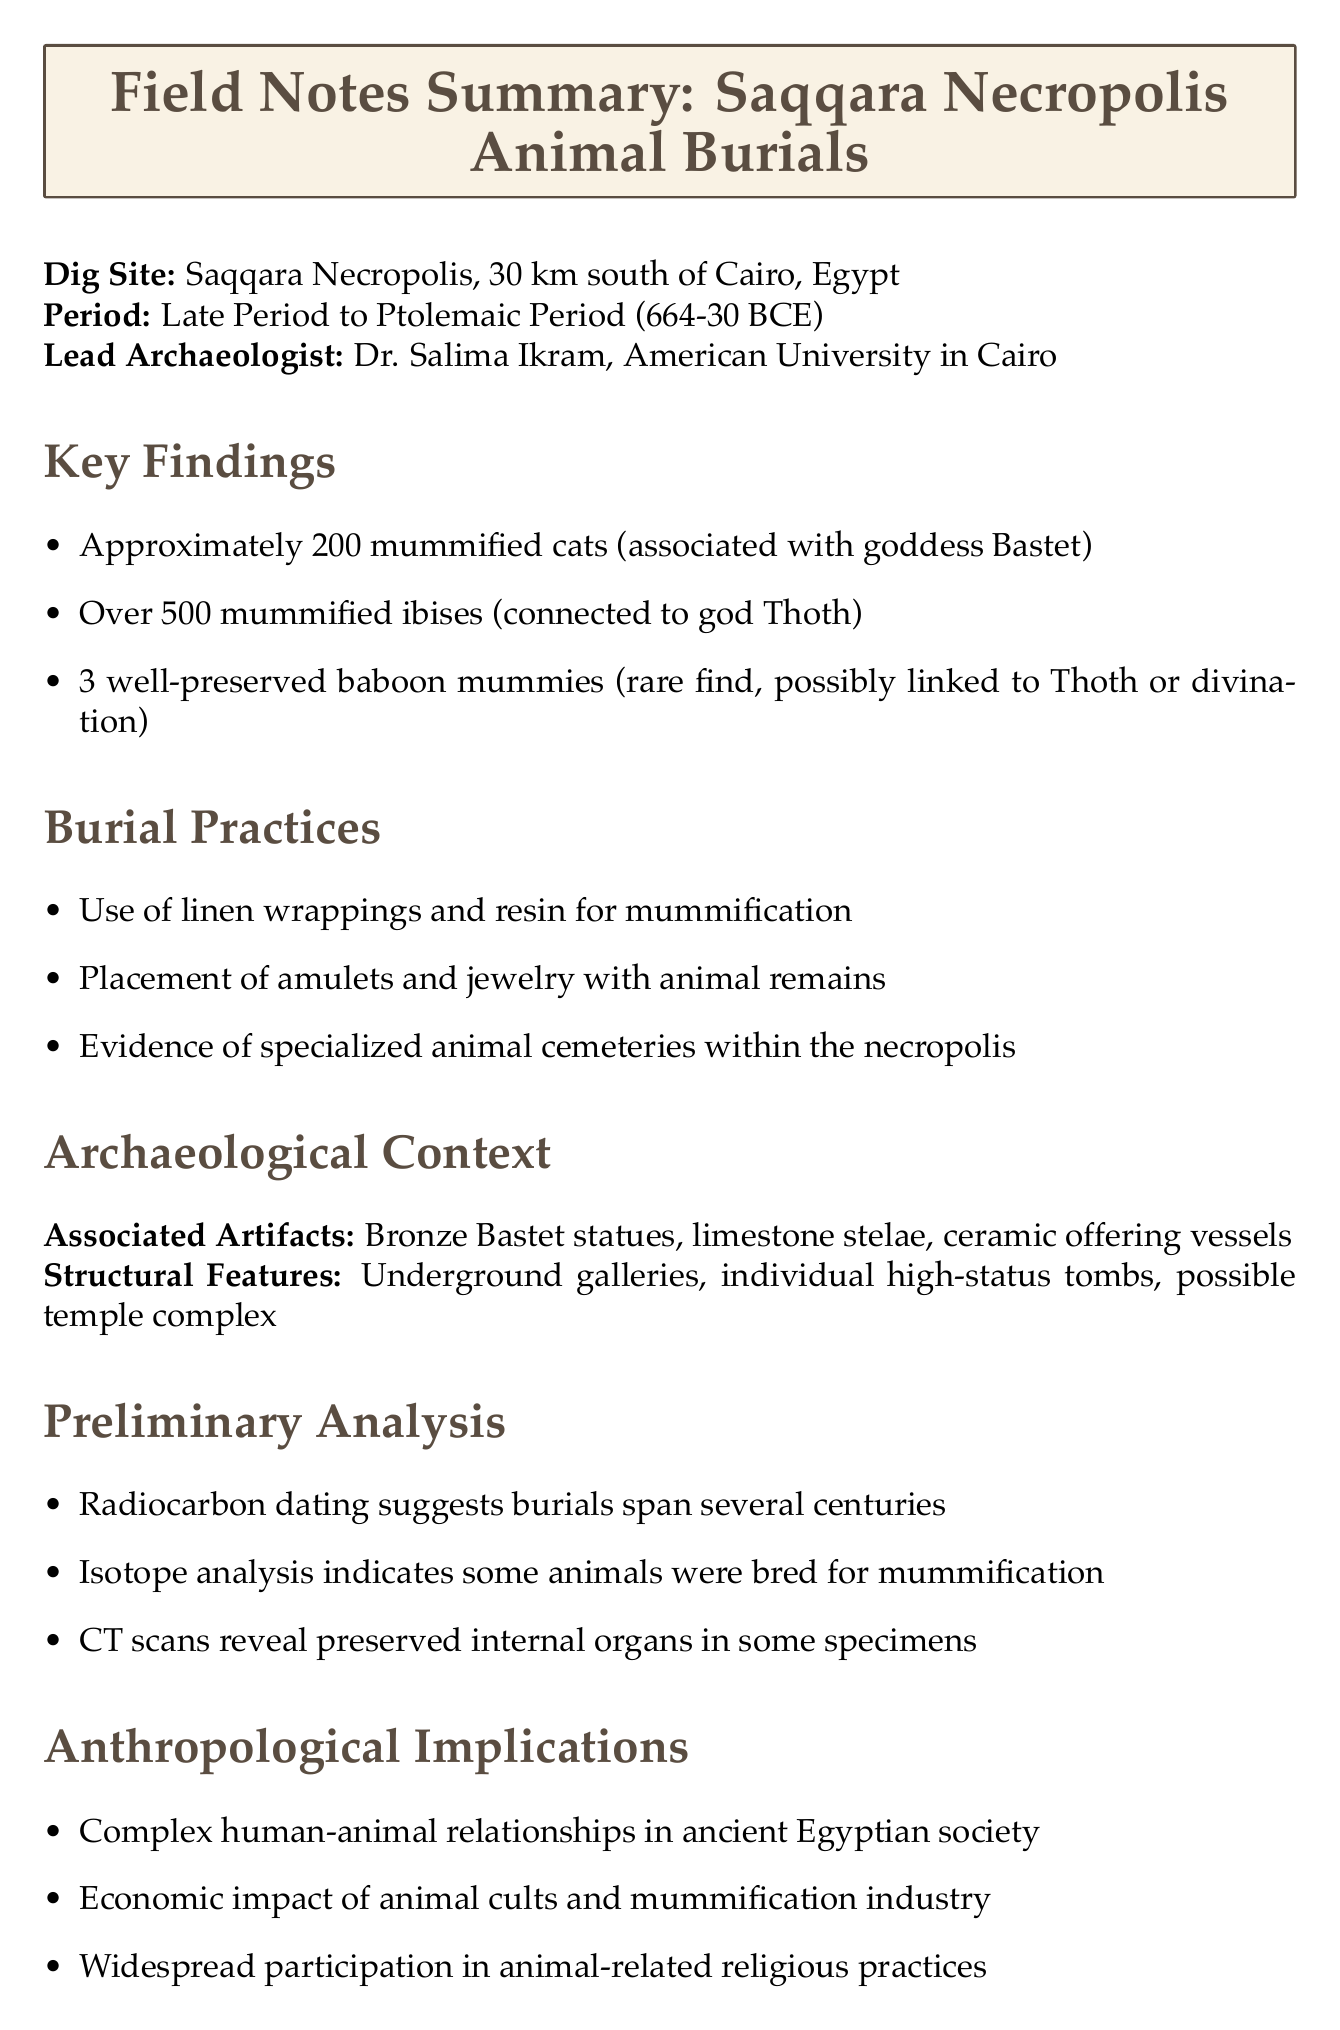What is the location of the dig site? The location of the dig site is specified in the document as 30 km south of Cairo, Egypt.
Answer: 30 km south of Cairo, Egypt Who is the lead archaeologist? The document provides the name and affiliation of the lead archaeologist involved in the dig.
Answer: Dr. Salima Ikram How many mummified cats were found? The number of mummified cats is specifically mentioned in the findings section of the document.
Answer: Approximately 200 mummified cats What animal is associated with the goddess Bastet? The document indicates which species is linked to the goddess Bastet, highlighting its religious significance.
Answer: Cats What type of analysis suggests that some animals were bred specifically for mummification? The type of analysis that provides insights into the breeding of animals is noted in the preliminary analysis section.
Answer: Isotope analysis Which god is the ibis connected to? The document directly states the god related to the mummified ibises found during the excavation.
Answer: Thoth What burial practices were observed at the site? The document lists specific practices related to the burials within the necropolis.
Answer: Use of linen wrappings and resin for mummification What is one of the conservation challenges mentioned? The document outlines specific challenges regarding the conservation of mummified remains, indicating the need for careful handling.
Answer: Fragility of mummified remains What future research direction involves DNA analysis? The document highlights future research directions and mentions a specific focus on genetic analysis of the mummified animals.
Answer: DNA analysis to determine genetic diversity and origins 